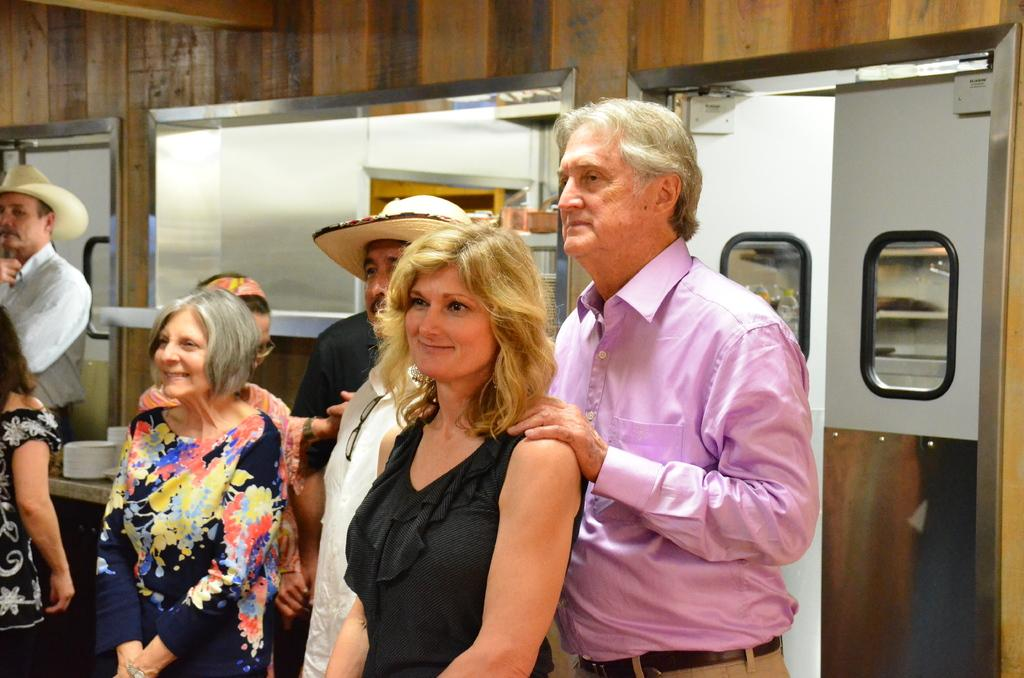What is happening in the image? There are people standing in the image. What can be seen in the background of the image? There is a wooden wall in the background of the image. Are there any openings in the wooden wall? Yes, there are doors in the wooden wall. How many cats are sitting on the doors in the image? There are no cats present in the image; it only features people standing and a wooden wall with doors. 